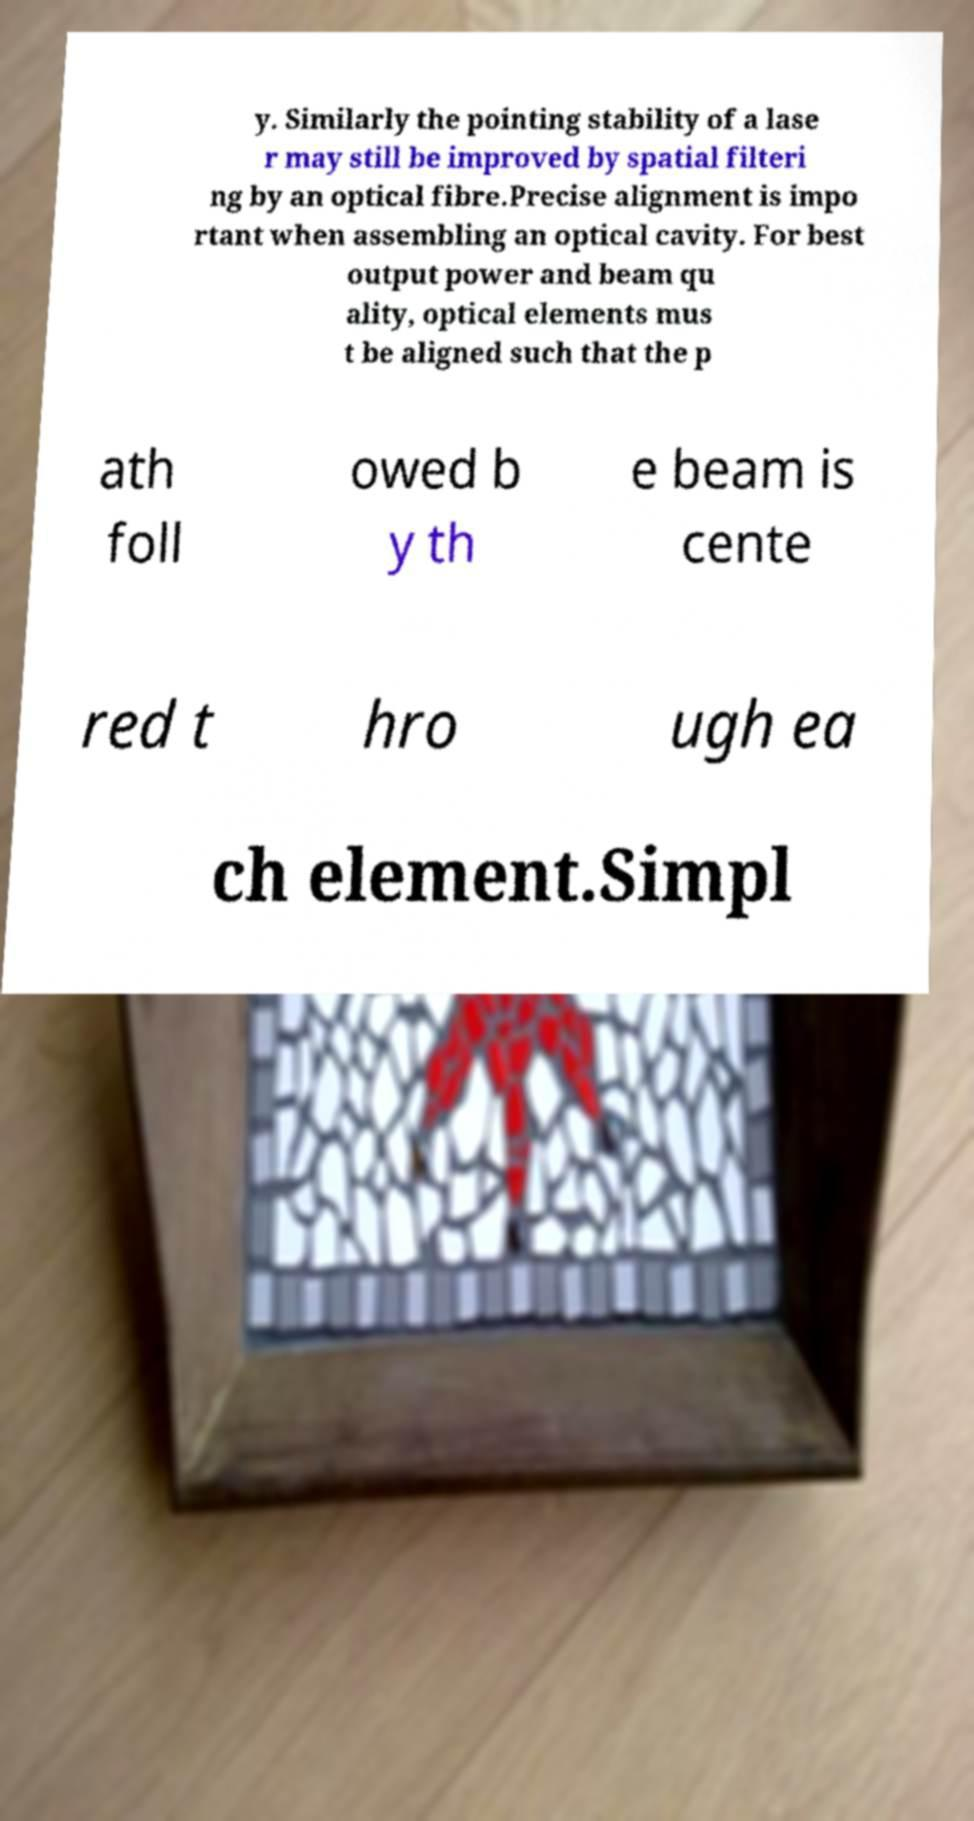Please identify and transcribe the text found in this image. y. Similarly the pointing stability of a lase r may still be improved by spatial filteri ng by an optical fibre.Precise alignment is impo rtant when assembling an optical cavity. For best output power and beam qu ality, optical elements mus t be aligned such that the p ath foll owed b y th e beam is cente red t hro ugh ea ch element.Simpl 